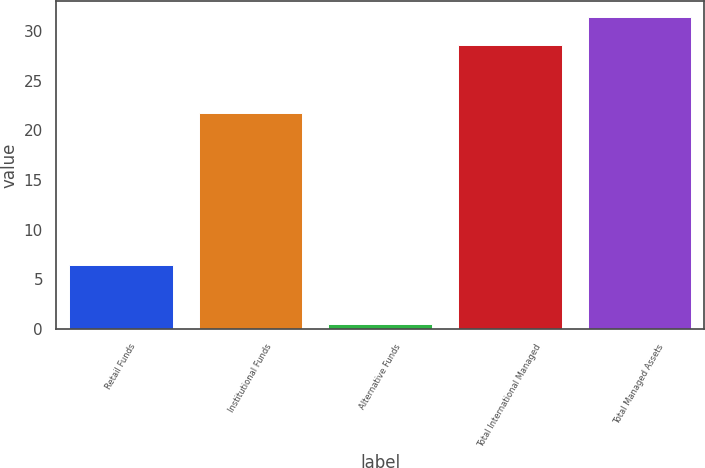<chart> <loc_0><loc_0><loc_500><loc_500><bar_chart><fcel>Retail Funds<fcel>Institutional Funds<fcel>Alternative Funds<fcel>Total International Managed<fcel>Total Managed Assets<nl><fcel>6.4<fcel>21.7<fcel>0.5<fcel>28.6<fcel>31.41<nl></chart> 